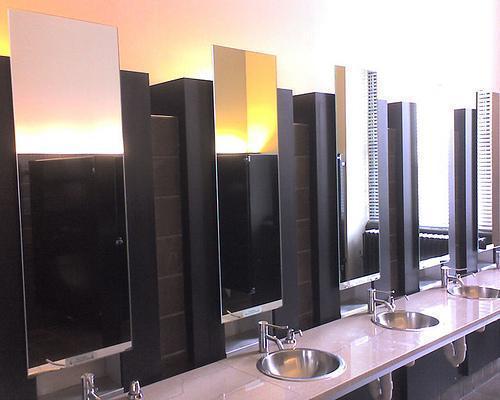What type of building is this bathroom likely to be in?
Select the accurate response from the four choices given to answer the question.
Options: House, business, library, school. Business. 